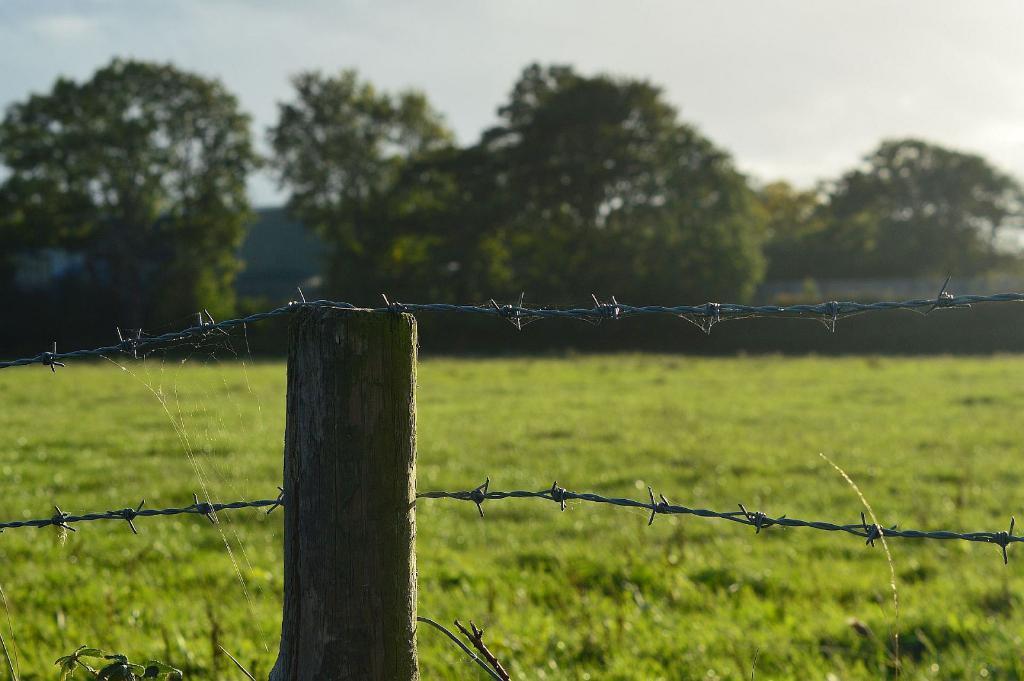Can you describe this image briefly? In this image I can see few trees,green grass and fencing. The sky is in white and blue color. 